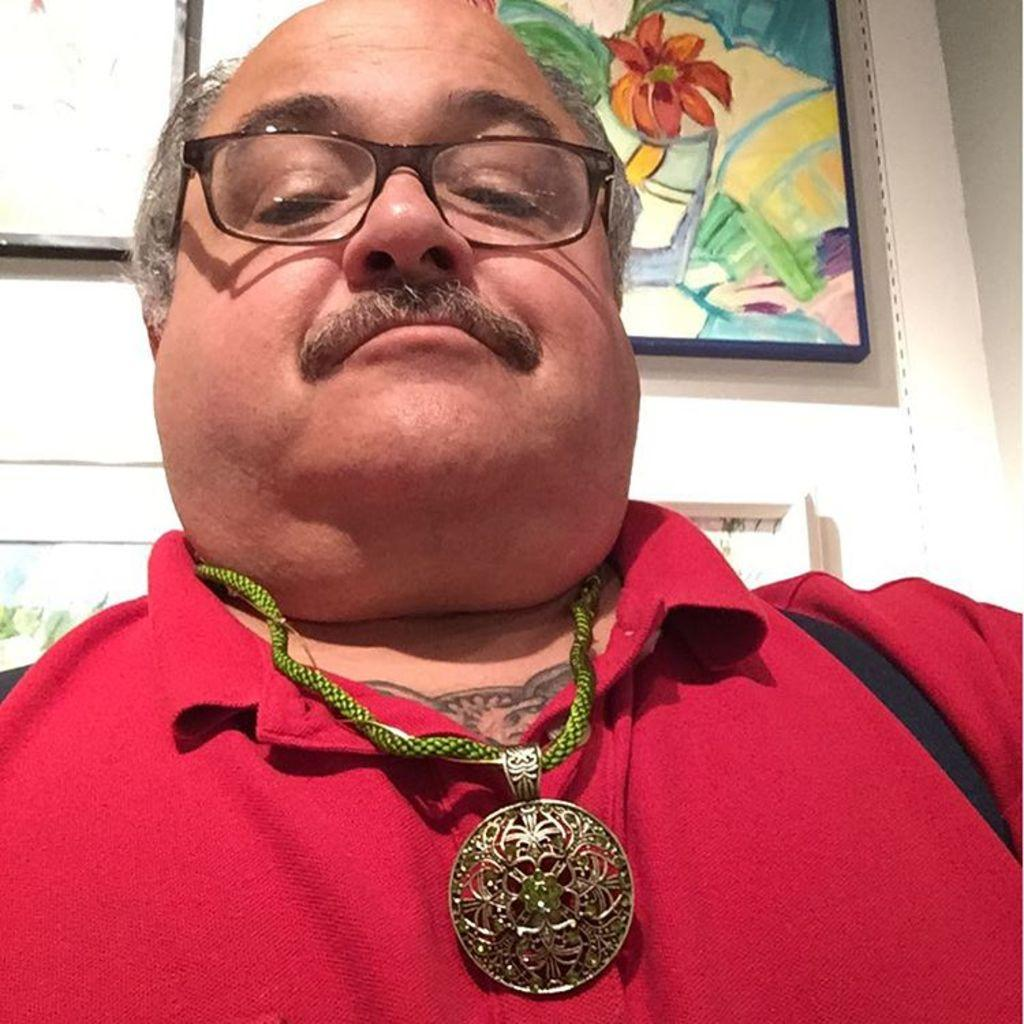Who is present in the image? There is a man in the image. What is the man wearing? The man is wearing a red T-shirt. What type of accessory can be seen in the image? There is a chain with a locket in the image. What can be seen in the background of the image? There are frames on the wall in the background of the image. What type of quilt is being used to cover the swing in the image? There is no swing or quilt present in the image. 